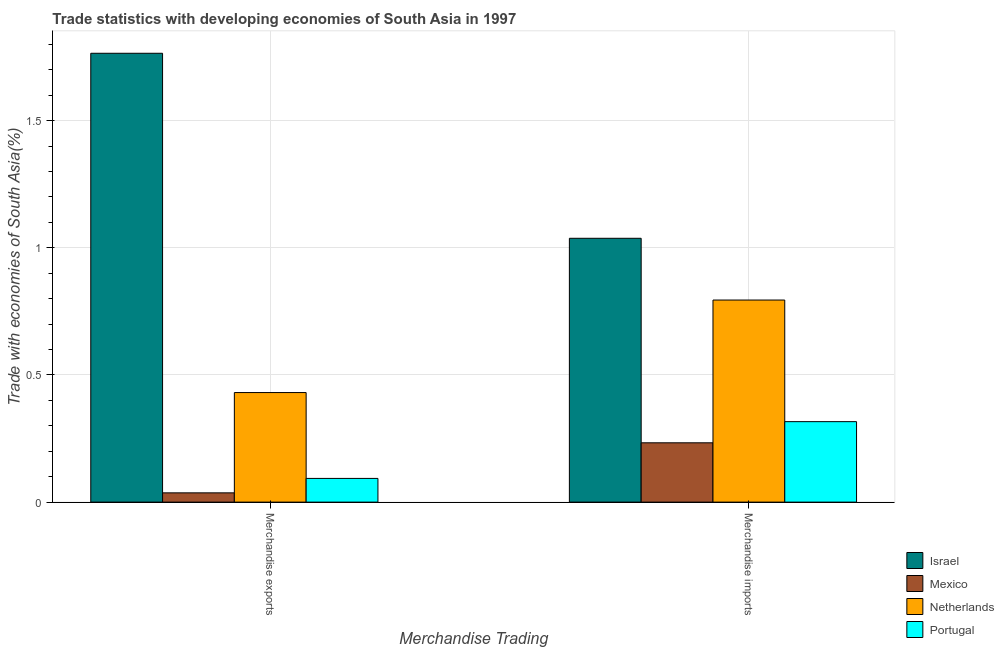How many different coloured bars are there?
Provide a succinct answer. 4. How many groups of bars are there?
Your answer should be very brief. 2. Are the number of bars per tick equal to the number of legend labels?
Make the answer very short. Yes. Are the number of bars on each tick of the X-axis equal?
Give a very brief answer. Yes. How many bars are there on the 1st tick from the left?
Give a very brief answer. 4. How many bars are there on the 1st tick from the right?
Make the answer very short. 4. What is the merchandise exports in Israel?
Make the answer very short. 1.76. Across all countries, what is the maximum merchandise exports?
Your answer should be compact. 1.76. Across all countries, what is the minimum merchandise imports?
Make the answer very short. 0.23. In which country was the merchandise exports maximum?
Your answer should be compact. Israel. In which country was the merchandise imports minimum?
Provide a succinct answer. Mexico. What is the total merchandise imports in the graph?
Ensure brevity in your answer.  2.38. What is the difference between the merchandise exports in Netherlands and that in Israel?
Keep it short and to the point. -1.33. What is the difference between the merchandise exports in Israel and the merchandise imports in Portugal?
Provide a succinct answer. 1.45. What is the average merchandise imports per country?
Offer a terse response. 0.6. What is the difference between the merchandise imports and merchandise exports in Mexico?
Your response must be concise. 0.2. In how many countries, is the merchandise exports greater than 1.7 %?
Your answer should be compact. 1. What is the ratio of the merchandise imports in Portugal to that in Mexico?
Give a very brief answer. 1.36. In how many countries, is the merchandise imports greater than the average merchandise imports taken over all countries?
Your answer should be very brief. 2. What does the 2nd bar from the right in Merchandise exports represents?
Offer a very short reply. Netherlands. What is the difference between two consecutive major ticks on the Y-axis?
Offer a very short reply. 0.5. Are the values on the major ticks of Y-axis written in scientific E-notation?
Your answer should be compact. No. Does the graph contain grids?
Offer a very short reply. Yes. How many legend labels are there?
Offer a very short reply. 4. How are the legend labels stacked?
Ensure brevity in your answer.  Vertical. What is the title of the graph?
Give a very brief answer. Trade statistics with developing economies of South Asia in 1997. Does "Belize" appear as one of the legend labels in the graph?
Give a very brief answer. No. What is the label or title of the X-axis?
Give a very brief answer. Merchandise Trading. What is the label or title of the Y-axis?
Offer a terse response. Trade with economies of South Asia(%). What is the Trade with economies of South Asia(%) in Israel in Merchandise exports?
Ensure brevity in your answer.  1.76. What is the Trade with economies of South Asia(%) of Mexico in Merchandise exports?
Provide a succinct answer. 0.04. What is the Trade with economies of South Asia(%) in Netherlands in Merchandise exports?
Ensure brevity in your answer.  0.43. What is the Trade with economies of South Asia(%) of Portugal in Merchandise exports?
Provide a short and direct response. 0.09. What is the Trade with economies of South Asia(%) in Israel in Merchandise imports?
Provide a succinct answer. 1.04. What is the Trade with economies of South Asia(%) in Mexico in Merchandise imports?
Ensure brevity in your answer.  0.23. What is the Trade with economies of South Asia(%) in Netherlands in Merchandise imports?
Keep it short and to the point. 0.79. What is the Trade with economies of South Asia(%) in Portugal in Merchandise imports?
Provide a succinct answer. 0.32. Across all Merchandise Trading, what is the maximum Trade with economies of South Asia(%) of Israel?
Keep it short and to the point. 1.76. Across all Merchandise Trading, what is the maximum Trade with economies of South Asia(%) in Mexico?
Make the answer very short. 0.23. Across all Merchandise Trading, what is the maximum Trade with economies of South Asia(%) in Netherlands?
Offer a terse response. 0.79. Across all Merchandise Trading, what is the maximum Trade with economies of South Asia(%) in Portugal?
Make the answer very short. 0.32. Across all Merchandise Trading, what is the minimum Trade with economies of South Asia(%) in Israel?
Your answer should be compact. 1.04. Across all Merchandise Trading, what is the minimum Trade with economies of South Asia(%) in Mexico?
Your answer should be very brief. 0.04. Across all Merchandise Trading, what is the minimum Trade with economies of South Asia(%) in Netherlands?
Offer a very short reply. 0.43. Across all Merchandise Trading, what is the minimum Trade with economies of South Asia(%) of Portugal?
Offer a terse response. 0.09. What is the total Trade with economies of South Asia(%) in Israel in the graph?
Offer a very short reply. 2.8. What is the total Trade with economies of South Asia(%) of Mexico in the graph?
Your response must be concise. 0.27. What is the total Trade with economies of South Asia(%) of Netherlands in the graph?
Ensure brevity in your answer.  1.23. What is the total Trade with economies of South Asia(%) of Portugal in the graph?
Offer a terse response. 0.41. What is the difference between the Trade with economies of South Asia(%) in Israel in Merchandise exports and that in Merchandise imports?
Your response must be concise. 0.73. What is the difference between the Trade with economies of South Asia(%) of Mexico in Merchandise exports and that in Merchandise imports?
Offer a very short reply. -0.2. What is the difference between the Trade with economies of South Asia(%) of Netherlands in Merchandise exports and that in Merchandise imports?
Give a very brief answer. -0.36. What is the difference between the Trade with economies of South Asia(%) of Portugal in Merchandise exports and that in Merchandise imports?
Give a very brief answer. -0.22. What is the difference between the Trade with economies of South Asia(%) in Israel in Merchandise exports and the Trade with economies of South Asia(%) in Mexico in Merchandise imports?
Keep it short and to the point. 1.53. What is the difference between the Trade with economies of South Asia(%) of Israel in Merchandise exports and the Trade with economies of South Asia(%) of Netherlands in Merchandise imports?
Make the answer very short. 0.97. What is the difference between the Trade with economies of South Asia(%) in Israel in Merchandise exports and the Trade with economies of South Asia(%) in Portugal in Merchandise imports?
Provide a short and direct response. 1.45. What is the difference between the Trade with economies of South Asia(%) in Mexico in Merchandise exports and the Trade with economies of South Asia(%) in Netherlands in Merchandise imports?
Make the answer very short. -0.76. What is the difference between the Trade with economies of South Asia(%) in Mexico in Merchandise exports and the Trade with economies of South Asia(%) in Portugal in Merchandise imports?
Provide a short and direct response. -0.28. What is the difference between the Trade with economies of South Asia(%) in Netherlands in Merchandise exports and the Trade with economies of South Asia(%) in Portugal in Merchandise imports?
Give a very brief answer. 0.11. What is the average Trade with economies of South Asia(%) in Israel per Merchandise Trading?
Your answer should be compact. 1.4. What is the average Trade with economies of South Asia(%) in Mexico per Merchandise Trading?
Keep it short and to the point. 0.13. What is the average Trade with economies of South Asia(%) in Netherlands per Merchandise Trading?
Ensure brevity in your answer.  0.61. What is the average Trade with economies of South Asia(%) of Portugal per Merchandise Trading?
Your answer should be very brief. 0.2. What is the difference between the Trade with economies of South Asia(%) of Israel and Trade with economies of South Asia(%) of Mexico in Merchandise exports?
Offer a very short reply. 1.73. What is the difference between the Trade with economies of South Asia(%) in Israel and Trade with economies of South Asia(%) in Netherlands in Merchandise exports?
Keep it short and to the point. 1.33. What is the difference between the Trade with economies of South Asia(%) in Israel and Trade with economies of South Asia(%) in Portugal in Merchandise exports?
Provide a short and direct response. 1.67. What is the difference between the Trade with economies of South Asia(%) in Mexico and Trade with economies of South Asia(%) in Netherlands in Merchandise exports?
Provide a succinct answer. -0.39. What is the difference between the Trade with economies of South Asia(%) of Mexico and Trade with economies of South Asia(%) of Portugal in Merchandise exports?
Offer a very short reply. -0.06. What is the difference between the Trade with economies of South Asia(%) of Netherlands and Trade with economies of South Asia(%) of Portugal in Merchandise exports?
Provide a short and direct response. 0.34. What is the difference between the Trade with economies of South Asia(%) in Israel and Trade with economies of South Asia(%) in Mexico in Merchandise imports?
Give a very brief answer. 0.8. What is the difference between the Trade with economies of South Asia(%) of Israel and Trade with economies of South Asia(%) of Netherlands in Merchandise imports?
Your answer should be compact. 0.24. What is the difference between the Trade with economies of South Asia(%) of Israel and Trade with economies of South Asia(%) of Portugal in Merchandise imports?
Your answer should be compact. 0.72. What is the difference between the Trade with economies of South Asia(%) of Mexico and Trade with economies of South Asia(%) of Netherlands in Merchandise imports?
Provide a short and direct response. -0.56. What is the difference between the Trade with economies of South Asia(%) in Mexico and Trade with economies of South Asia(%) in Portugal in Merchandise imports?
Offer a very short reply. -0.08. What is the difference between the Trade with economies of South Asia(%) of Netherlands and Trade with economies of South Asia(%) of Portugal in Merchandise imports?
Your answer should be compact. 0.48. What is the ratio of the Trade with economies of South Asia(%) of Israel in Merchandise exports to that in Merchandise imports?
Provide a short and direct response. 1.7. What is the ratio of the Trade with economies of South Asia(%) of Mexico in Merchandise exports to that in Merchandise imports?
Your answer should be very brief. 0.16. What is the ratio of the Trade with economies of South Asia(%) of Netherlands in Merchandise exports to that in Merchandise imports?
Offer a terse response. 0.54. What is the ratio of the Trade with economies of South Asia(%) of Portugal in Merchandise exports to that in Merchandise imports?
Your answer should be compact. 0.29. What is the difference between the highest and the second highest Trade with economies of South Asia(%) in Israel?
Your answer should be very brief. 0.73. What is the difference between the highest and the second highest Trade with economies of South Asia(%) of Mexico?
Offer a very short reply. 0.2. What is the difference between the highest and the second highest Trade with economies of South Asia(%) in Netherlands?
Give a very brief answer. 0.36. What is the difference between the highest and the second highest Trade with economies of South Asia(%) in Portugal?
Offer a very short reply. 0.22. What is the difference between the highest and the lowest Trade with economies of South Asia(%) in Israel?
Your response must be concise. 0.73. What is the difference between the highest and the lowest Trade with economies of South Asia(%) of Mexico?
Give a very brief answer. 0.2. What is the difference between the highest and the lowest Trade with economies of South Asia(%) in Netherlands?
Your answer should be very brief. 0.36. What is the difference between the highest and the lowest Trade with economies of South Asia(%) of Portugal?
Provide a succinct answer. 0.22. 